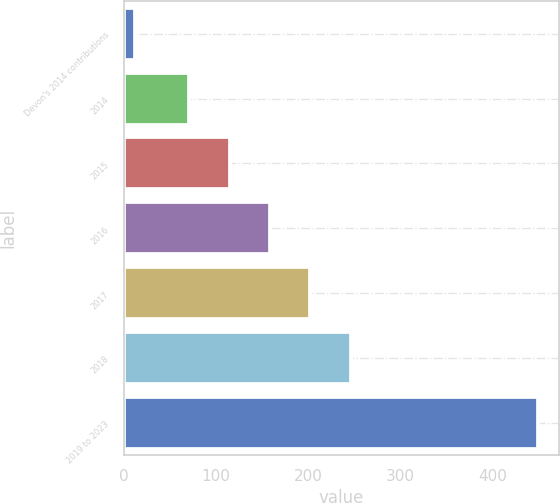Convert chart to OTSL. <chart><loc_0><loc_0><loc_500><loc_500><bar_chart><fcel>Devon's 2014 contributions<fcel>2014<fcel>2015<fcel>2016<fcel>2017<fcel>2018<fcel>2019 to 2023<nl><fcel>12<fcel>71<fcel>114.8<fcel>158.6<fcel>202.4<fcel>246.2<fcel>450<nl></chart> 